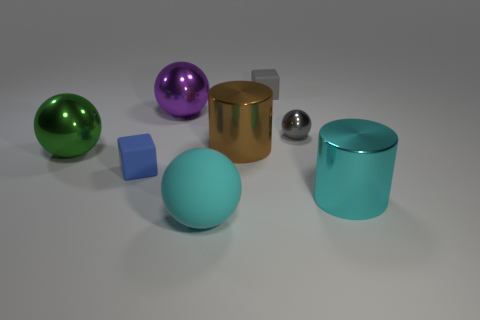What number of brown objects are the same shape as the gray shiny thing?
Ensure brevity in your answer.  0. How many brown things are either large balls or tiny cylinders?
Provide a succinct answer. 0. What size is the rubber thing that is behind the small object that is right of the small gray rubber block?
Your answer should be compact. Small. What material is the large cyan thing that is the same shape as the purple object?
Your response must be concise. Rubber. How many green spheres are the same size as the cyan ball?
Your answer should be compact. 1. Does the purple metal ball have the same size as the green object?
Give a very brief answer. Yes. What size is the shiny thing that is right of the purple object and to the left of the gray matte object?
Your response must be concise. Large. Are there more balls that are to the right of the large brown cylinder than big metallic cylinders that are behind the large matte thing?
Your answer should be very brief. No. The tiny metal thing that is the same shape as the big cyan rubber thing is what color?
Provide a short and direct response. Gray. There is a big object to the left of the small blue cube; is it the same color as the rubber sphere?
Give a very brief answer. No. 